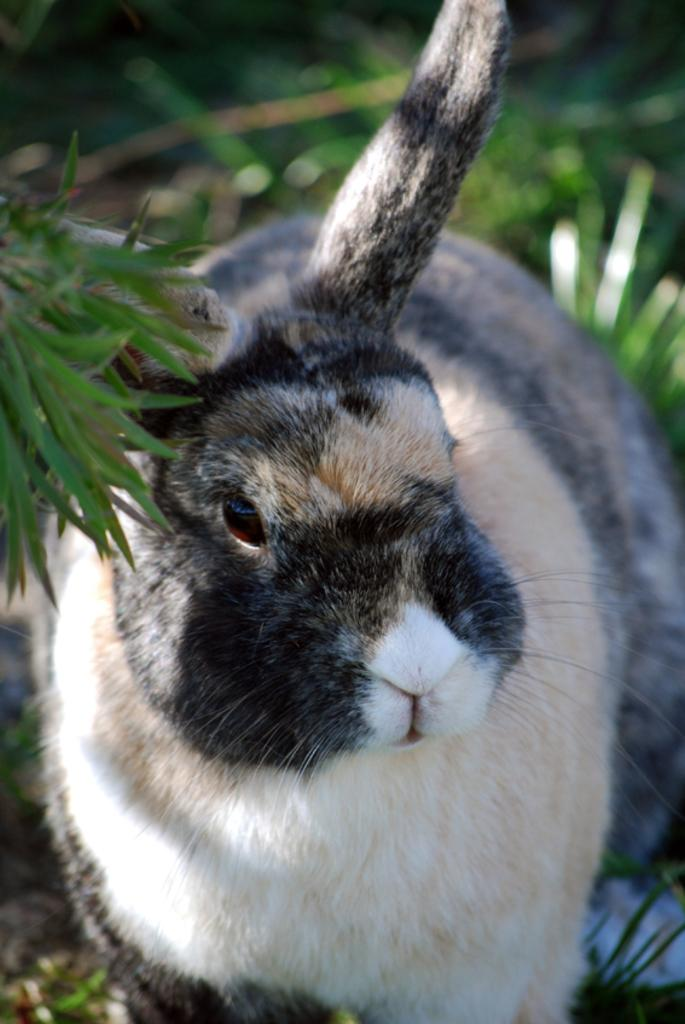What type of animal is in the image? There is a rabbit in the image. What else can be seen in the image besides the rabbit? There are plants in the image. What hobbies does the rabbit have in the image? There is no information about the rabbit's hobbies in the image. What disease is the rabbit suffering from in the image? There is no indication of any disease in the image; the rabbit appears to be healthy. 